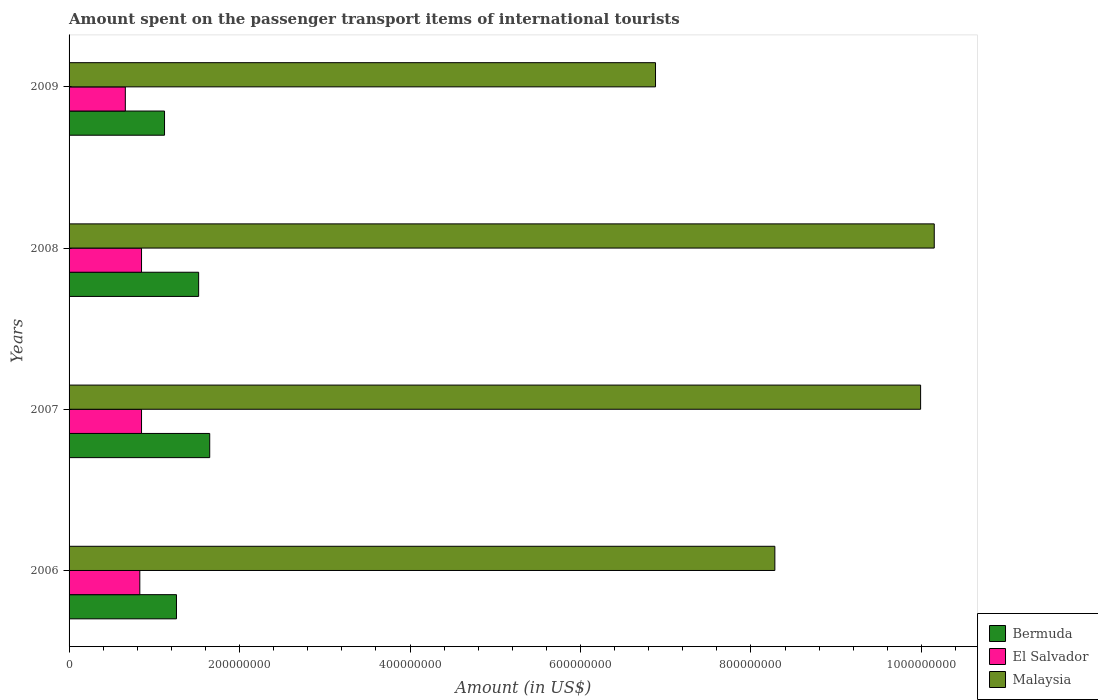How many groups of bars are there?
Offer a very short reply. 4. Are the number of bars per tick equal to the number of legend labels?
Give a very brief answer. Yes. Are the number of bars on each tick of the Y-axis equal?
Ensure brevity in your answer.  Yes. How many bars are there on the 4th tick from the bottom?
Provide a short and direct response. 3. What is the label of the 2nd group of bars from the top?
Give a very brief answer. 2008. In how many cases, is the number of bars for a given year not equal to the number of legend labels?
Keep it short and to the point. 0. What is the amount spent on the passenger transport items of international tourists in Bermuda in 2006?
Your answer should be compact. 1.26e+08. Across all years, what is the maximum amount spent on the passenger transport items of international tourists in El Salvador?
Make the answer very short. 8.50e+07. Across all years, what is the minimum amount spent on the passenger transport items of international tourists in El Salvador?
Offer a very short reply. 6.60e+07. In which year was the amount spent on the passenger transport items of international tourists in Malaysia minimum?
Provide a succinct answer. 2009. What is the total amount spent on the passenger transport items of international tourists in Malaysia in the graph?
Provide a succinct answer. 3.53e+09. What is the difference between the amount spent on the passenger transport items of international tourists in El Salvador in 2006 and that in 2007?
Your answer should be very brief. -2.00e+06. What is the difference between the amount spent on the passenger transport items of international tourists in Malaysia in 2006 and the amount spent on the passenger transport items of international tourists in El Salvador in 2007?
Give a very brief answer. 7.43e+08. What is the average amount spent on the passenger transport items of international tourists in Bermuda per year?
Your answer should be compact. 1.39e+08. In the year 2006, what is the difference between the amount spent on the passenger transport items of international tourists in El Salvador and amount spent on the passenger transport items of international tourists in Malaysia?
Provide a succinct answer. -7.45e+08. What is the ratio of the amount spent on the passenger transport items of international tourists in Bermuda in 2007 to that in 2008?
Offer a very short reply. 1.09. Is the amount spent on the passenger transport items of international tourists in El Salvador in 2006 less than that in 2008?
Offer a terse response. Yes. Is the difference between the amount spent on the passenger transport items of international tourists in El Salvador in 2006 and 2007 greater than the difference between the amount spent on the passenger transport items of international tourists in Malaysia in 2006 and 2007?
Provide a short and direct response. Yes. What is the difference between the highest and the second highest amount spent on the passenger transport items of international tourists in Bermuda?
Offer a very short reply. 1.30e+07. What is the difference between the highest and the lowest amount spent on the passenger transport items of international tourists in Bermuda?
Offer a terse response. 5.30e+07. In how many years, is the amount spent on the passenger transport items of international tourists in Malaysia greater than the average amount spent on the passenger transport items of international tourists in Malaysia taken over all years?
Keep it short and to the point. 2. Is the sum of the amount spent on the passenger transport items of international tourists in El Salvador in 2006 and 2007 greater than the maximum amount spent on the passenger transport items of international tourists in Bermuda across all years?
Offer a very short reply. Yes. What does the 1st bar from the top in 2006 represents?
Make the answer very short. Malaysia. What does the 2nd bar from the bottom in 2007 represents?
Ensure brevity in your answer.  El Salvador. How many bars are there?
Keep it short and to the point. 12. How many years are there in the graph?
Keep it short and to the point. 4. Are the values on the major ticks of X-axis written in scientific E-notation?
Offer a terse response. No. Does the graph contain grids?
Make the answer very short. No. Where does the legend appear in the graph?
Offer a very short reply. Bottom right. How many legend labels are there?
Provide a short and direct response. 3. How are the legend labels stacked?
Your response must be concise. Vertical. What is the title of the graph?
Offer a terse response. Amount spent on the passenger transport items of international tourists. What is the label or title of the X-axis?
Offer a terse response. Amount (in US$). What is the label or title of the Y-axis?
Give a very brief answer. Years. What is the Amount (in US$) of Bermuda in 2006?
Provide a short and direct response. 1.26e+08. What is the Amount (in US$) in El Salvador in 2006?
Give a very brief answer. 8.30e+07. What is the Amount (in US$) in Malaysia in 2006?
Your response must be concise. 8.28e+08. What is the Amount (in US$) in Bermuda in 2007?
Provide a succinct answer. 1.65e+08. What is the Amount (in US$) of El Salvador in 2007?
Provide a succinct answer. 8.50e+07. What is the Amount (in US$) in Malaysia in 2007?
Offer a terse response. 9.99e+08. What is the Amount (in US$) of Bermuda in 2008?
Your answer should be compact. 1.52e+08. What is the Amount (in US$) in El Salvador in 2008?
Your response must be concise. 8.50e+07. What is the Amount (in US$) in Malaysia in 2008?
Offer a terse response. 1.02e+09. What is the Amount (in US$) of Bermuda in 2009?
Ensure brevity in your answer.  1.12e+08. What is the Amount (in US$) of El Salvador in 2009?
Your response must be concise. 6.60e+07. What is the Amount (in US$) in Malaysia in 2009?
Keep it short and to the point. 6.88e+08. Across all years, what is the maximum Amount (in US$) in Bermuda?
Your response must be concise. 1.65e+08. Across all years, what is the maximum Amount (in US$) of El Salvador?
Your response must be concise. 8.50e+07. Across all years, what is the maximum Amount (in US$) in Malaysia?
Provide a succinct answer. 1.02e+09. Across all years, what is the minimum Amount (in US$) in Bermuda?
Offer a very short reply. 1.12e+08. Across all years, what is the minimum Amount (in US$) of El Salvador?
Offer a terse response. 6.60e+07. Across all years, what is the minimum Amount (in US$) of Malaysia?
Offer a very short reply. 6.88e+08. What is the total Amount (in US$) of Bermuda in the graph?
Offer a very short reply. 5.55e+08. What is the total Amount (in US$) in El Salvador in the graph?
Provide a succinct answer. 3.19e+08. What is the total Amount (in US$) in Malaysia in the graph?
Your answer should be very brief. 3.53e+09. What is the difference between the Amount (in US$) in Bermuda in 2006 and that in 2007?
Your answer should be compact. -3.90e+07. What is the difference between the Amount (in US$) of Malaysia in 2006 and that in 2007?
Make the answer very short. -1.71e+08. What is the difference between the Amount (in US$) in Bermuda in 2006 and that in 2008?
Provide a succinct answer. -2.60e+07. What is the difference between the Amount (in US$) of Malaysia in 2006 and that in 2008?
Keep it short and to the point. -1.87e+08. What is the difference between the Amount (in US$) of Bermuda in 2006 and that in 2009?
Offer a very short reply. 1.40e+07. What is the difference between the Amount (in US$) in El Salvador in 2006 and that in 2009?
Make the answer very short. 1.70e+07. What is the difference between the Amount (in US$) of Malaysia in 2006 and that in 2009?
Provide a short and direct response. 1.40e+08. What is the difference between the Amount (in US$) of Bermuda in 2007 and that in 2008?
Your answer should be compact. 1.30e+07. What is the difference between the Amount (in US$) of Malaysia in 2007 and that in 2008?
Provide a succinct answer. -1.60e+07. What is the difference between the Amount (in US$) of Bermuda in 2007 and that in 2009?
Offer a very short reply. 5.30e+07. What is the difference between the Amount (in US$) of El Salvador in 2007 and that in 2009?
Keep it short and to the point. 1.90e+07. What is the difference between the Amount (in US$) of Malaysia in 2007 and that in 2009?
Ensure brevity in your answer.  3.11e+08. What is the difference between the Amount (in US$) of Bermuda in 2008 and that in 2009?
Your answer should be compact. 4.00e+07. What is the difference between the Amount (in US$) of El Salvador in 2008 and that in 2009?
Your answer should be compact. 1.90e+07. What is the difference between the Amount (in US$) in Malaysia in 2008 and that in 2009?
Make the answer very short. 3.27e+08. What is the difference between the Amount (in US$) of Bermuda in 2006 and the Amount (in US$) of El Salvador in 2007?
Your answer should be compact. 4.10e+07. What is the difference between the Amount (in US$) in Bermuda in 2006 and the Amount (in US$) in Malaysia in 2007?
Your response must be concise. -8.73e+08. What is the difference between the Amount (in US$) in El Salvador in 2006 and the Amount (in US$) in Malaysia in 2007?
Your response must be concise. -9.16e+08. What is the difference between the Amount (in US$) in Bermuda in 2006 and the Amount (in US$) in El Salvador in 2008?
Ensure brevity in your answer.  4.10e+07. What is the difference between the Amount (in US$) in Bermuda in 2006 and the Amount (in US$) in Malaysia in 2008?
Make the answer very short. -8.89e+08. What is the difference between the Amount (in US$) in El Salvador in 2006 and the Amount (in US$) in Malaysia in 2008?
Offer a very short reply. -9.32e+08. What is the difference between the Amount (in US$) of Bermuda in 2006 and the Amount (in US$) of El Salvador in 2009?
Ensure brevity in your answer.  6.00e+07. What is the difference between the Amount (in US$) of Bermuda in 2006 and the Amount (in US$) of Malaysia in 2009?
Your answer should be compact. -5.62e+08. What is the difference between the Amount (in US$) in El Salvador in 2006 and the Amount (in US$) in Malaysia in 2009?
Ensure brevity in your answer.  -6.05e+08. What is the difference between the Amount (in US$) in Bermuda in 2007 and the Amount (in US$) in El Salvador in 2008?
Your answer should be very brief. 8.00e+07. What is the difference between the Amount (in US$) in Bermuda in 2007 and the Amount (in US$) in Malaysia in 2008?
Offer a very short reply. -8.50e+08. What is the difference between the Amount (in US$) in El Salvador in 2007 and the Amount (in US$) in Malaysia in 2008?
Your response must be concise. -9.30e+08. What is the difference between the Amount (in US$) of Bermuda in 2007 and the Amount (in US$) of El Salvador in 2009?
Your answer should be compact. 9.90e+07. What is the difference between the Amount (in US$) in Bermuda in 2007 and the Amount (in US$) in Malaysia in 2009?
Your answer should be compact. -5.23e+08. What is the difference between the Amount (in US$) in El Salvador in 2007 and the Amount (in US$) in Malaysia in 2009?
Keep it short and to the point. -6.03e+08. What is the difference between the Amount (in US$) in Bermuda in 2008 and the Amount (in US$) in El Salvador in 2009?
Provide a succinct answer. 8.60e+07. What is the difference between the Amount (in US$) of Bermuda in 2008 and the Amount (in US$) of Malaysia in 2009?
Offer a very short reply. -5.36e+08. What is the difference between the Amount (in US$) of El Salvador in 2008 and the Amount (in US$) of Malaysia in 2009?
Your answer should be compact. -6.03e+08. What is the average Amount (in US$) of Bermuda per year?
Ensure brevity in your answer.  1.39e+08. What is the average Amount (in US$) of El Salvador per year?
Offer a terse response. 7.98e+07. What is the average Amount (in US$) in Malaysia per year?
Make the answer very short. 8.82e+08. In the year 2006, what is the difference between the Amount (in US$) in Bermuda and Amount (in US$) in El Salvador?
Your answer should be compact. 4.30e+07. In the year 2006, what is the difference between the Amount (in US$) in Bermuda and Amount (in US$) in Malaysia?
Your answer should be very brief. -7.02e+08. In the year 2006, what is the difference between the Amount (in US$) of El Salvador and Amount (in US$) of Malaysia?
Offer a terse response. -7.45e+08. In the year 2007, what is the difference between the Amount (in US$) of Bermuda and Amount (in US$) of El Salvador?
Keep it short and to the point. 8.00e+07. In the year 2007, what is the difference between the Amount (in US$) in Bermuda and Amount (in US$) in Malaysia?
Your answer should be compact. -8.34e+08. In the year 2007, what is the difference between the Amount (in US$) in El Salvador and Amount (in US$) in Malaysia?
Provide a succinct answer. -9.14e+08. In the year 2008, what is the difference between the Amount (in US$) of Bermuda and Amount (in US$) of El Salvador?
Give a very brief answer. 6.70e+07. In the year 2008, what is the difference between the Amount (in US$) of Bermuda and Amount (in US$) of Malaysia?
Offer a very short reply. -8.63e+08. In the year 2008, what is the difference between the Amount (in US$) in El Salvador and Amount (in US$) in Malaysia?
Provide a short and direct response. -9.30e+08. In the year 2009, what is the difference between the Amount (in US$) of Bermuda and Amount (in US$) of El Salvador?
Your answer should be compact. 4.60e+07. In the year 2009, what is the difference between the Amount (in US$) of Bermuda and Amount (in US$) of Malaysia?
Make the answer very short. -5.76e+08. In the year 2009, what is the difference between the Amount (in US$) of El Salvador and Amount (in US$) of Malaysia?
Ensure brevity in your answer.  -6.22e+08. What is the ratio of the Amount (in US$) in Bermuda in 2006 to that in 2007?
Your answer should be very brief. 0.76. What is the ratio of the Amount (in US$) of El Salvador in 2006 to that in 2007?
Ensure brevity in your answer.  0.98. What is the ratio of the Amount (in US$) in Malaysia in 2006 to that in 2007?
Make the answer very short. 0.83. What is the ratio of the Amount (in US$) of Bermuda in 2006 to that in 2008?
Provide a succinct answer. 0.83. What is the ratio of the Amount (in US$) in El Salvador in 2006 to that in 2008?
Your answer should be compact. 0.98. What is the ratio of the Amount (in US$) of Malaysia in 2006 to that in 2008?
Give a very brief answer. 0.82. What is the ratio of the Amount (in US$) of Bermuda in 2006 to that in 2009?
Provide a short and direct response. 1.12. What is the ratio of the Amount (in US$) of El Salvador in 2006 to that in 2009?
Ensure brevity in your answer.  1.26. What is the ratio of the Amount (in US$) of Malaysia in 2006 to that in 2009?
Give a very brief answer. 1.2. What is the ratio of the Amount (in US$) of Bermuda in 2007 to that in 2008?
Provide a short and direct response. 1.09. What is the ratio of the Amount (in US$) in El Salvador in 2007 to that in 2008?
Ensure brevity in your answer.  1. What is the ratio of the Amount (in US$) of Malaysia in 2007 to that in 2008?
Ensure brevity in your answer.  0.98. What is the ratio of the Amount (in US$) in Bermuda in 2007 to that in 2009?
Keep it short and to the point. 1.47. What is the ratio of the Amount (in US$) in El Salvador in 2007 to that in 2009?
Make the answer very short. 1.29. What is the ratio of the Amount (in US$) of Malaysia in 2007 to that in 2009?
Give a very brief answer. 1.45. What is the ratio of the Amount (in US$) in Bermuda in 2008 to that in 2009?
Offer a very short reply. 1.36. What is the ratio of the Amount (in US$) in El Salvador in 2008 to that in 2009?
Give a very brief answer. 1.29. What is the ratio of the Amount (in US$) of Malaysia in 2008 to that in 2009?
Ensure brevity in your answer.  1.48. What is the difference between the highest and the second highest Amount (in US$) in Bermuda?
Offer a very short reply. 1.30e+07. What is the difference between the highest and the second highest Amount (in US$) in El Salvador?
Give a very brief answer. 0. What is the difference between the highest and the second highest Amount (in US$) of Malaysia?
Make the answer very short. 1.60e+07. What is the difference between the highest and the lowest Amount (in US$) in Bermuda?
Keep it short and to the point. 5.30e+07. What is the difference between the highest and the lowest Amount (in US$) of El Salvador?
Offer a very short reply. 1.90e+07. What is the difference between the highest and the lowest Amount (in US$) of Malaysia?
Offer a very short reply. 3.27e+08. 